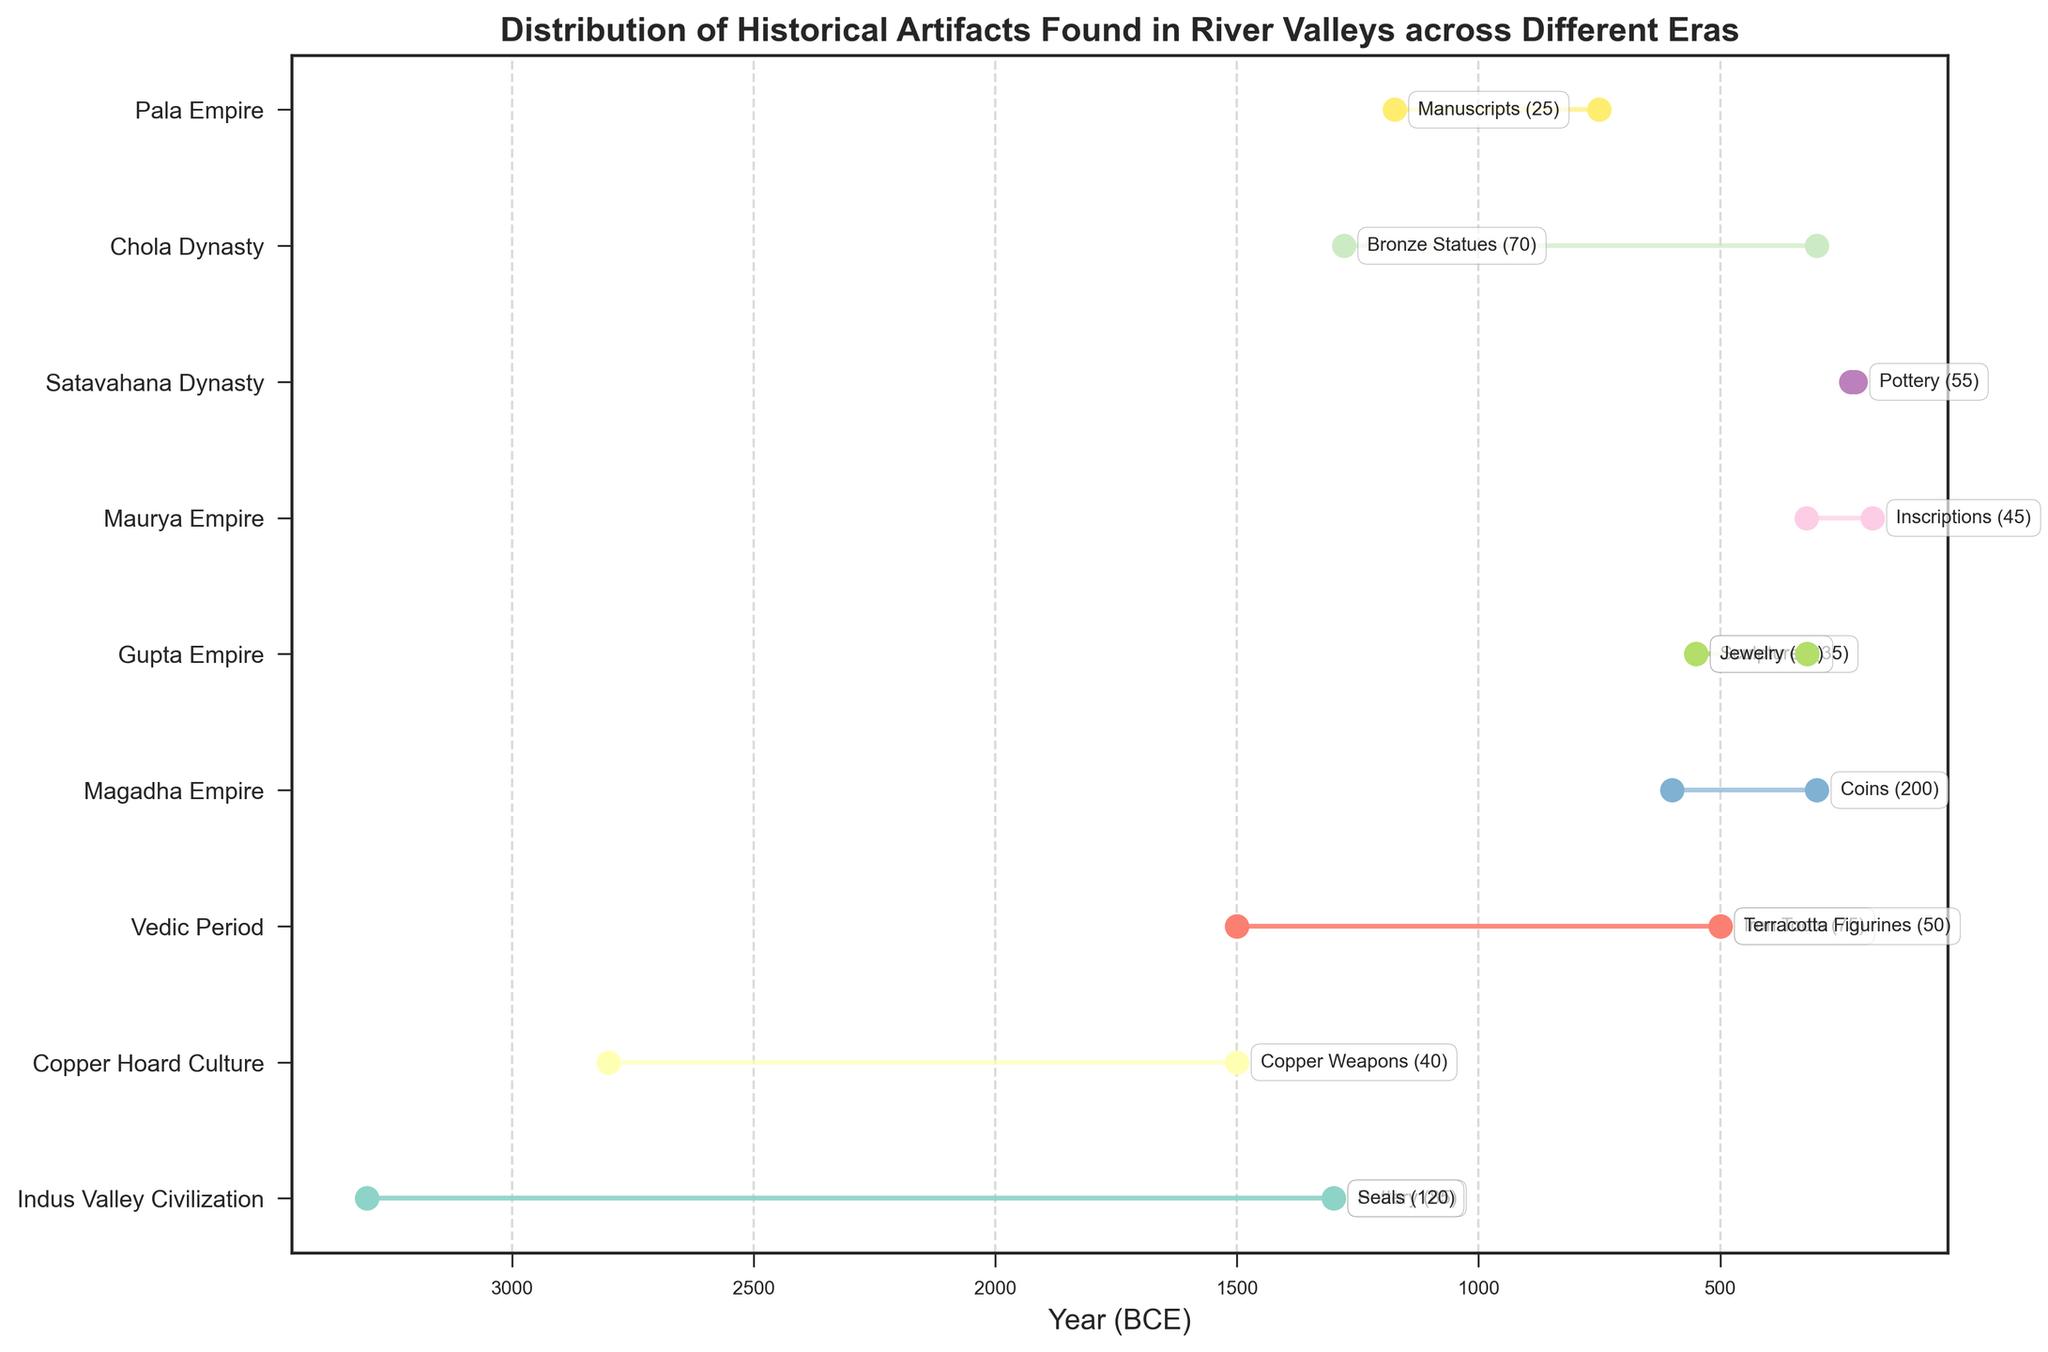What is the range of years for the artifacts found in the Indus Valley Civilization? The Indus Valley Civilization artifacts are retrieved from the Indus River, and span from the year 3300 BCE to 1300 BCE as shown on the plot.
Answer: 3300 BCE to 1300 BCE Which era has the most types of artifacts listed? The plot illustrates different eras and their associated artifacts. From the visualization, the Indus Valley Civilization has two types: Pottery and Seals. The others have one type each.
Answer: Indus Valley Civilization What is the difference in years between the Min Year (BCE) of the Copper Hoard Culture and the Max Year (BCE) of the Maurya Empire? The Min Year for the Copper Hoard Culture is 2800 BCE and the Max Year for the Maurya Empire is 185 BCE. The difference is calculated as 2800 - 185 = 2615 years.
Answer: 2615 years Which river valley has the most number of artifacts found and which era does it belong to? According to the plot, the Ganges River in the Magadha Empire era has the highest quantity of artifacts found, specifically coins totaling 200.
Answer: Ganges River, Magadha Empire Compare the Min Years (BCE) of the Vedic Period in the Ganges and Yamuna River Valleys and identify which one started earlier? The plot shows both Vedic Period River Valleys starting at 1500 BCE. Therefore, neither started earlier.
Answer: Both started at the same time What is the total quantity of artifacts found across all listed river valleys in the Gupta Empire? The Gupta Empire has artifacts in the Yamuna and Tungabhadra River Valleys. The quantities are 35 (Sculptures) and 60 (Jewelry) respectively. Summing these gives 35 + 60 = 95.
Answer: 95 Which artifact type spanning from 750 BCE to 1174 CE, associated with which era, and how many were found? The plot shows Manuscripts from the Pala Empire spanning from 750 BCE to 1174 CE, and 25 were found.
Answer: Manuscripts, Pala Empire, 25 